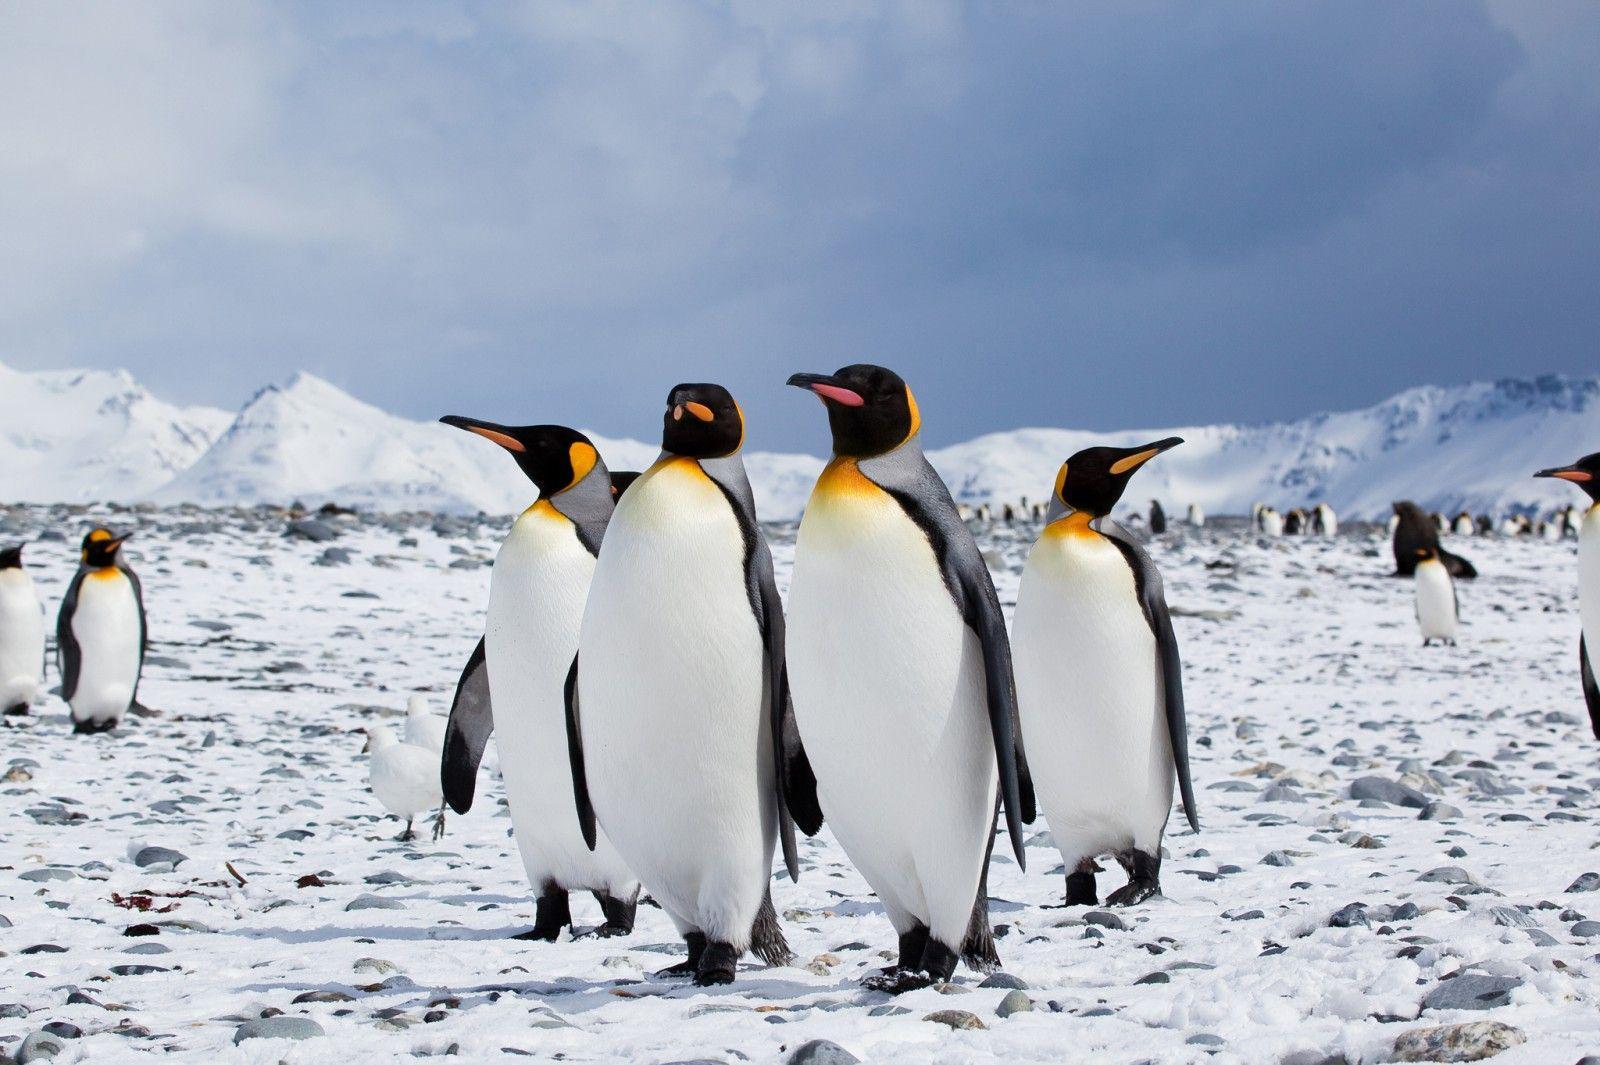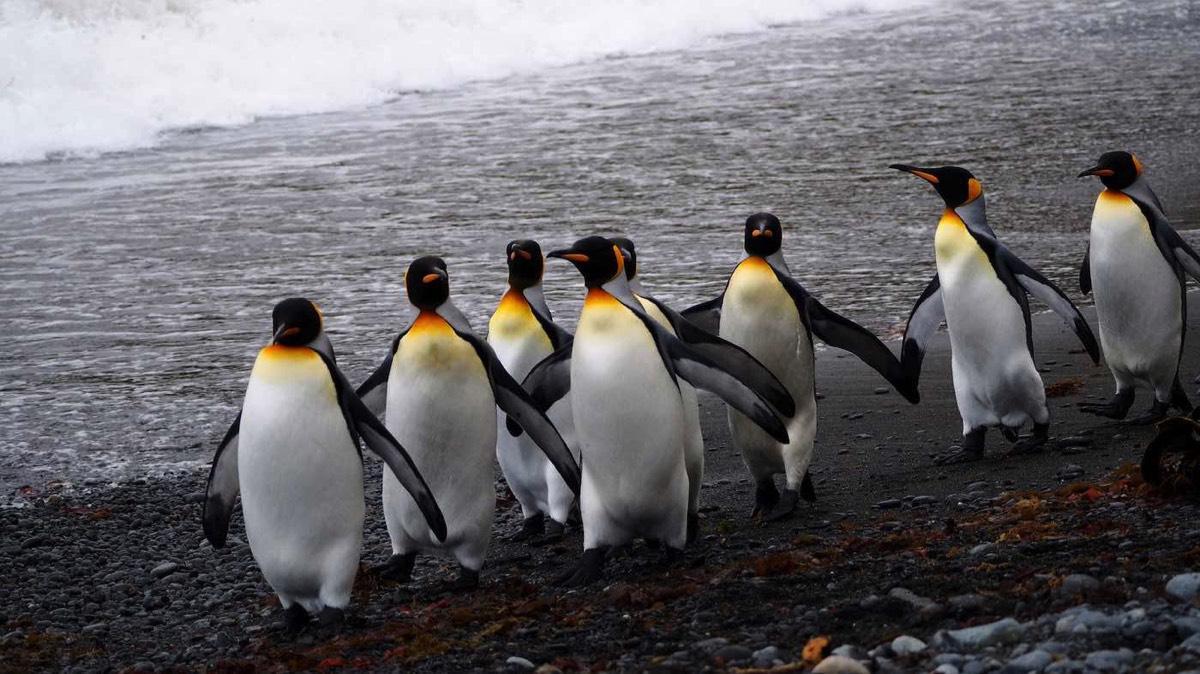The first image is the image on the left, the second image is the image on the right. Analyze the images presented: Is the assertion "The right image has the waters edge visible." valid? Answer yes or no. Yes. The first image is the image on the left, the second image is the image on the right. Analyze the images presented: Is the assertion "A waddle of penguins is standing in a snowy landscape in one of the images." valid? Answer yes or no. Yes. The first image is the image on the left, the second image is the image on the right. Evaluate the accuracy of this statement regarding the images: "There are no more than two animals in the image on the right.". Is it true? Answer yes or no. No. The first image is the image on the left, the second image is the image on the right. Considering the images on both sides, is "There are at most 4 penguins total in both images." valid? Answer yes or no. No. 